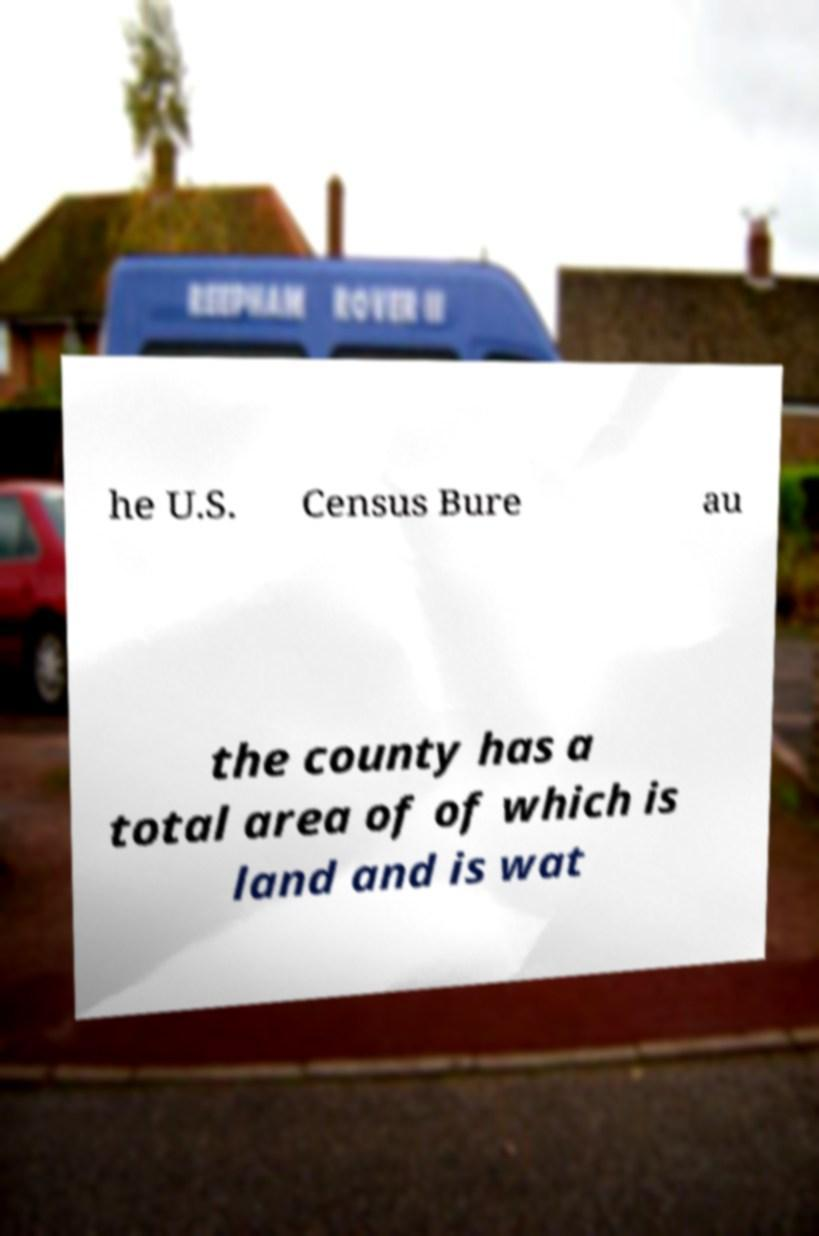For documentation purposes, I need the text within this image transcribed. Could you provide that? he U.S. Census Bure au the county has a total area of of which is land and is wat 